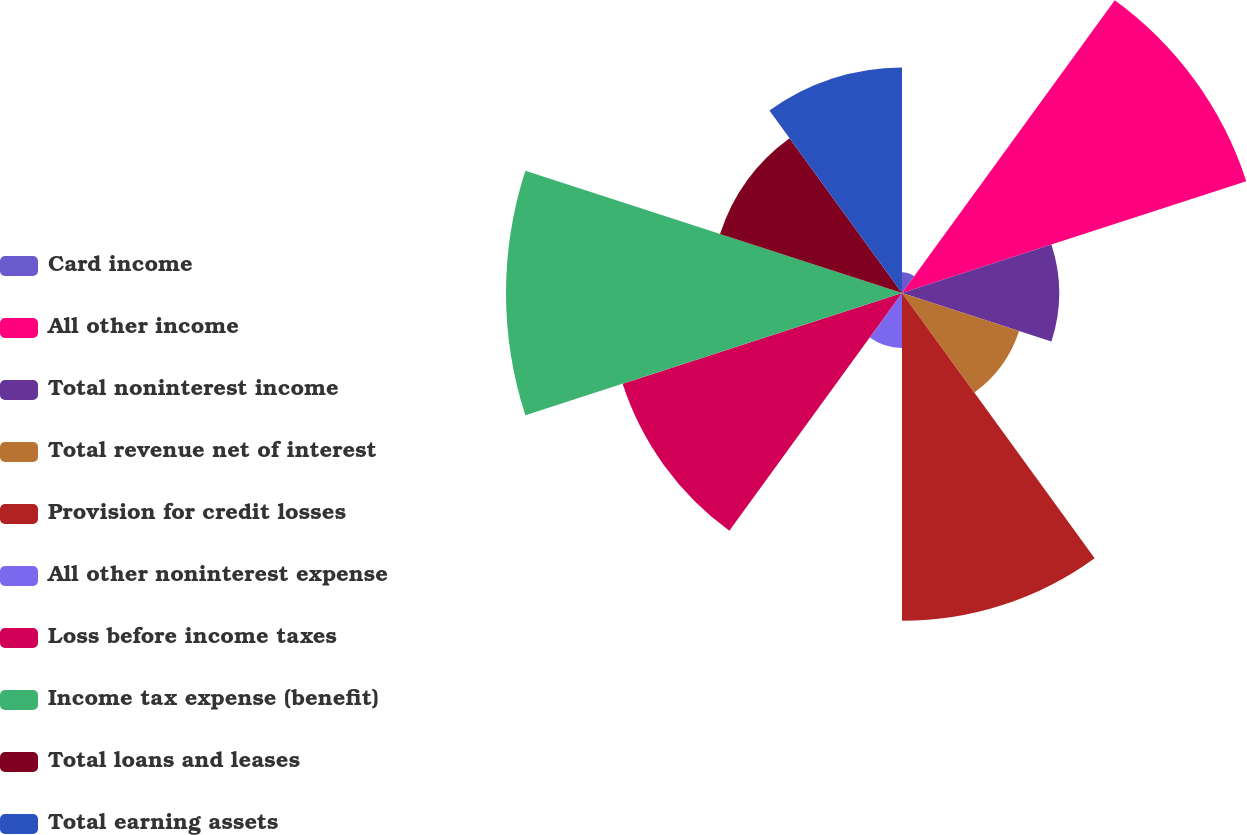Convert chart. <chart><loc_0><loc_0><loc_500><loc_500><pie_chart><fcel>Card income<fcel>All other income<fcel>Total noninterest income<fcel>Total revenue net of interest<fcel>Provision for credit losses<fcel>All other noninterest expense<fcel>Loss before income taxes<fcel>Income tax expense (benefit)<fcel>Total loans and leases<fcel>Total earning assets<nl><fcel>0.96%<fcel>16.82%<fcel>7.3%<fcel>5.72%<fcel>15.23%<fcel>2.55%<fcel>13.65%<fcel>18.4%<fcel>8.89%<fcel>10.48%<nl></chart> 